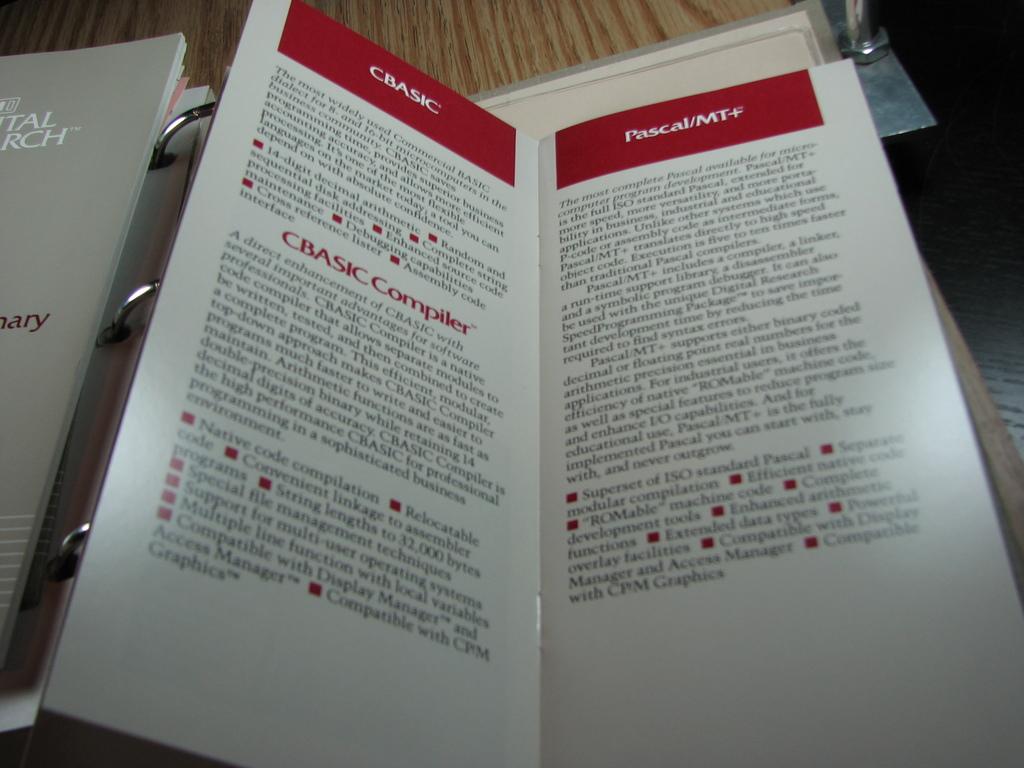What is the title of the second page?
Make the answer very short. Pascal/mt+. 